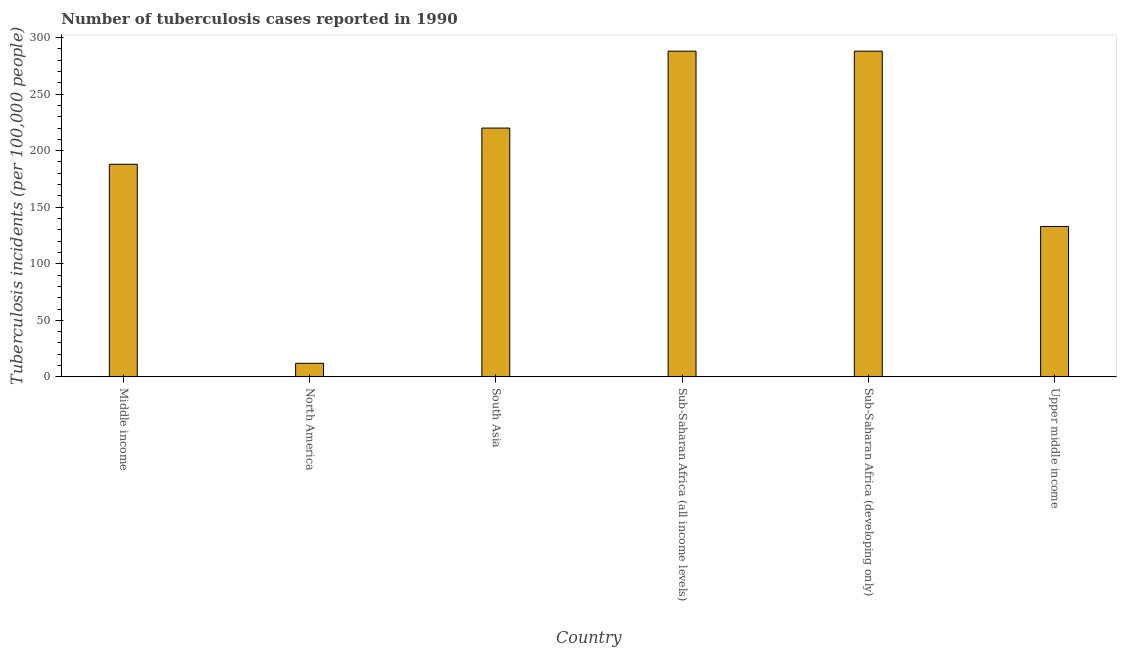Does the graph contain any zero values?
Your answer should be compact. No. Does the graph contain grids?
Offer a very short reply. No. What is the title of the graph?
Provide a succinct answer. Number of tuberculosis cases reported in 1990. What is the label or title of the Y-axis?
Your answer should be very brief. Tuberculosis incidents (per 100,0 people). What is the number of tuberculosis incidents in Middle income?
Your answer should be compact. 188. Across all countries, what is the maximum number of tuberculosis incidents?
Keep it short and to the point. 288. Across all countries, what is the minimum number of tuberculosis incidents?
Ensure brevity in your answer.  12. In which country was the number of tuberculosis incidents maximum?
Provide a short and direct response. Sub-Saharan Africa (all income levels). In which country was the number of tuberculosis incidents minimum?
Provide a succinct answer. North America. What is the sum of the number of tuberculosis incidents?
Offer a terse response. 1129. What is the difference between the number of tuberculosis incidents in South Asia and Sub-Saharan Africa (developing only)?
Offer a very short reply. -68. What is the average number of tuberculosis incidents per country?
Your answer should be very brief. 188.17. What is the median number of tuberculosis incidents?
Ensure brevity in your answer.  204. What is the ratio of the number of tuberculosis incidents in Middle income to that in South Asia?
Make the answer very short. 0.85. Is the sum of the number of tuberculosis incidents in Middle income and South Asia greater than the maximum number of tuberculosis incidents across all countries?
Provide a short and direct response. Yes. What is the difference between the highest and the lowest number of tuberculosis incidents?
Offer a very short reply. 276. How many bars are there?
Offer a terse response. 6. How many countries are there in the graph?
Offer a terse response. 6. What is the Tuberculosis incidents (per 100,000 people) of Middle income?
Your response must be concise. 188. What is the Tuberculosis incidents (per 100,000 people) of North America?
Provide a succinct answer. 12. What is the Tuberculosis incidents (per 100,000 people) of South Asia?
Your answer should be compact. 220. What is the Tuberculosis incidents (per 100,000 people) in Sub-Saharan Africa (all income levels)?
Your response must be concise. 288. What is the Tuberculosis incidents (per 100,000 people) in Sub-Saharan Africa (developing only)?
Provide a short and direct response. 288. What is the Tuberculosis incidents (per 100,000 people) in Upper middle income?
Your answer should be very brief. 133. What is the difference between the Tuberculosis incidents (per 100,000 people) in Middle income and North America?
Your answer should be very brief. 176. What is the difference between the Tuberculosis incidents (per 100,000 people) in Middle income and South Asia?
Provide a short and direct response. -32. What is the difference between the Tuberculosis incidents (per 100,000 people) in Middle income and Sub-Saharan Africa (all income levels)?
Offer a very short reply. -100. What is the difference between the Tuberculosis incidents (per 100,000 people) in Middle income and Sub-Saharan Africa (developing only)?
Provide a short and direct response. -100. What is the difference between the Tuberculosis incidents (per 100,000 people) in Middle income and Upper middle income?
Provide a short and direct response. 55. What is the difference between the Tuberculosis incidents (per 100,000 people) in North America and South Asia?
Your answer should be very brief. -208. What is the difference between the Tuberculosis incidents (per 100,000 people) in North America and Sub-Saharan Africa (all income levels)?
Keep it short and to the point. -276. What is the difference between the Tuberculosis incidents (per 100,000 people) in North America and Sub-Saharan Africa (developing only)?
Make the answer very short. -276. What is the difference between the Tuberculosis incidents (per 100,000 people) in North America and Upper middle income?
Your response must be concise. -121. What is the difference between the Tuberculosis incidents (per 100,000 people) in South Asia and Sub-Saharan Africa (all income levels)?
Ensure brevity in your answer.  -68. What is the difference between the Tuberculosis incidents (per 100,000 people) in South Asia and Sub-Saharan Africa (developing only)?
Keep it short and to the point. -68. What is the difference between the Tuberculosis incidents (per 100,000 people) in South Asia and Upper middle income?
Offer a very short reply. 87. What is the difference between the Tuberculosis incidents (per 100,000 people) in Sub-Saharan Africa (all income levels) and Sub-Saharan Africa (developing only)?
Offer a very short reply. 0. What is the difference between the Tuberculosis incidents (per 100,000 people) in Sub-Saharan Africa (all income levels) and Upper middle income?
Give a very brief answer. 155. What is the difference between the Tuberculosis incidents (per 100,000 people) in Sub-Saharan Africa (developing only) and Upper middle income?
Keep it short and to the point. 155. What is the ratio of the Tuberculosis incidents (per 100,000 people) in Middle income to that in North America?
Make the answer very short. 15.67. What is the ratio of the Tuberculosis incidents (per 100,000 people) in Middle income to that in South Asia?
Your answer should be very brief. 0.85. What is the ratio of the Tuberculosis incidents (per 100,000 people) in Middle income to that in Sub-Saharan Africa (all income levels)?
Provide a succinct answer. 0.65. What is the ratio of the Tuberculosis incidents (per 100,000 people) in Middle income to that in Sub-Saharan Africa (developing only)?
Ensure brevity in your answer.  0.65. What is the ratio of the Tuberculosis incidents (per 100,000 people) in Middle income to that in Upper middle income?
Offer a terse response. 1.41. What is the ratio of the Tuberculosis incidents (per 100,000 people) in North America to that in South Asia?
Provide a short and direct response. 0.06. What is the ratio of the Tuberculosis incidents (per 100,000 people) in North America to that in Sub-Saharan Africa (all income levels)?
Give a very brief answer. 0.04. What is the ratio of the Tuberculosis incidents (per 100,000 people) in North America to that in Sub-Saharan Africa (developing only)?
Provide a short and direct response. 0.04. What is the ratio of the Tuberculosis incidents (per 100,000 people) in North America to that in Upper middle income?
Offer a terse response. 0.09. What is the ratio of the Tuberculosis incidents (per 100,000 people) in South Asia to that in Sub-Saharan Africa (all income levels)?
Your response must be concise. 0.76. What is the ratio of the Tuberculosis incidents (per 100,000 people) in South Asia to that in Sub-Saharan Africa (developing only)?
Ensure brevity in your answer.  0.76. What is the ratio of the Tuberculosis incidents (per 100,000 people) in South Asia to that in Upper middle income?
Keep it short and to the point. 1.65. What is the ratio of the Tuberculosis incidents (per 100,000 people) in Sub-Saharan Africa (all income levels) to that in Upper middle income?
Your answer should be very brief. 2.17. What is the ratio of the Tuberculosis incidents (per 100,000 people) in Sub-Saharan Africa (developing only) to that in Upper middle income?
Give a very brief answer. 2.17. 